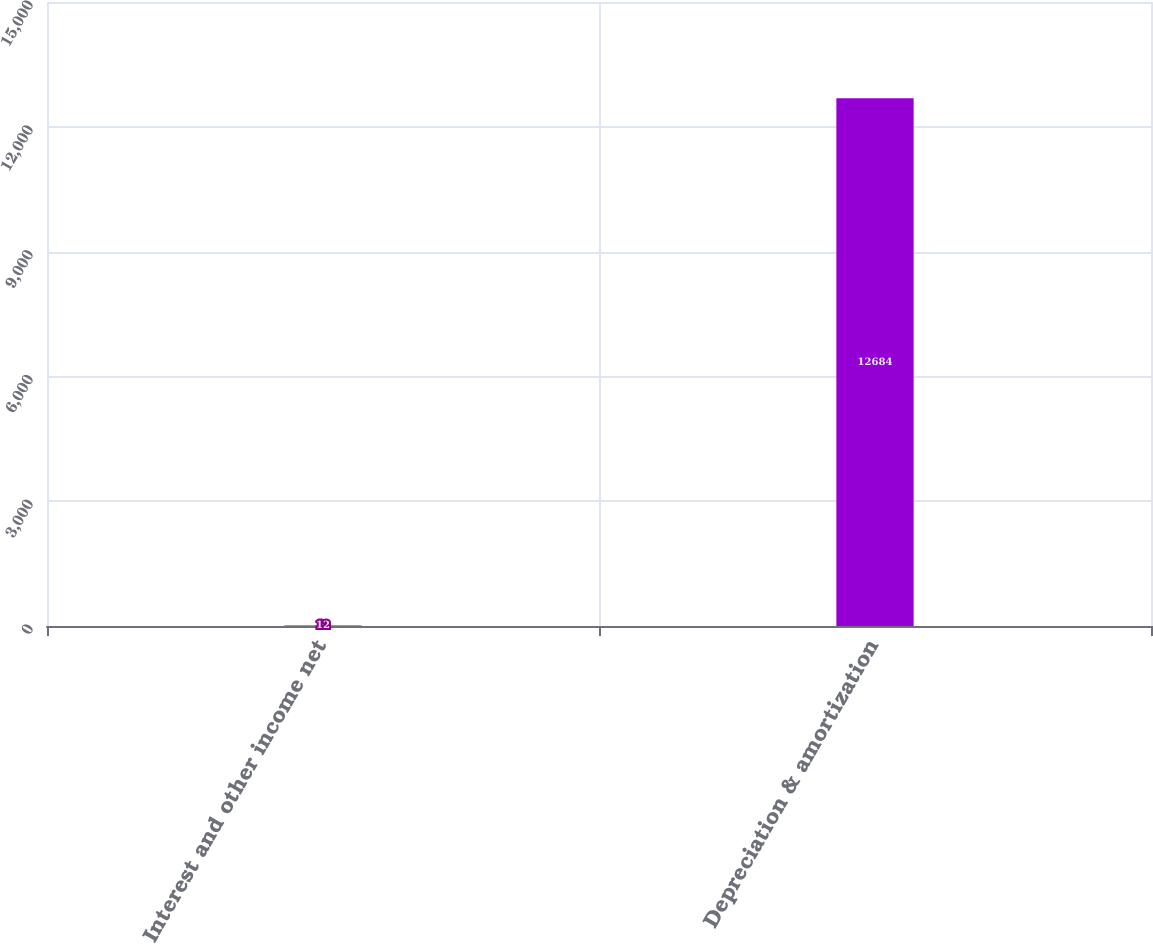Convert chart. <chart><loc_0><loc_0><loc_500><loc_500><bar_chart><fcel>Interest and other income net<fcel>Depreciation & amortization<nl><fcel>12<fcel>12684<nl></chart> 